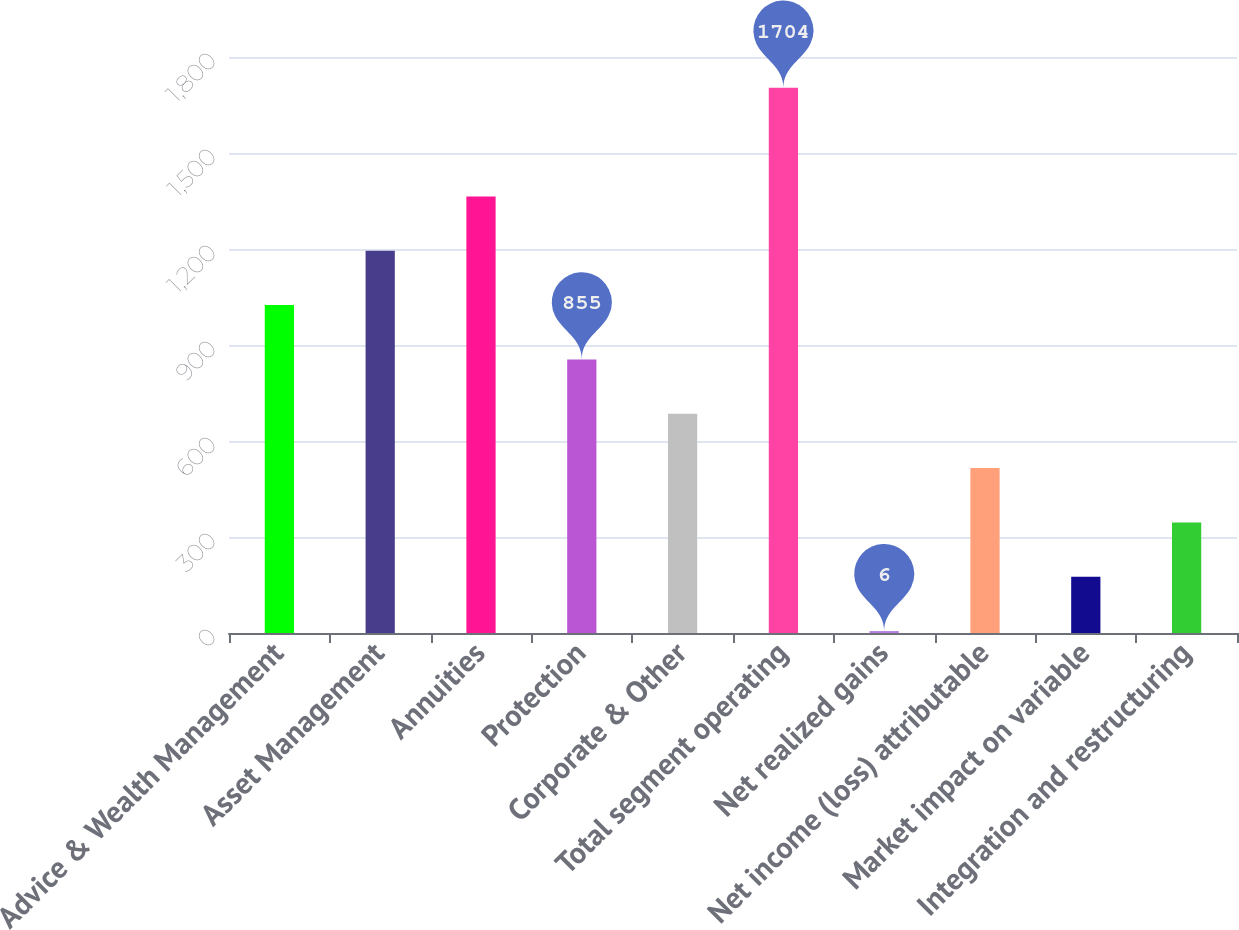<chart> <loc_0><loc_0><loc_500><loc_500><bar_chart><fcel>Advice & Wealth Management<fcel>Asset Management<fcel>Annuities<fcel>Protection<fcel>Corporate & Other<fcel>Total segment operating<fcel>Net realized gains<fcel>Net income (loss) attributable<fcel>Market impact on variable<fcel>Integration and restructuring<nl><fcel>1024.8<fcel>1194.6<fcel>1364.4<fcel>855<fcel>685.2<fcel>1704<fcel>6<fcel>515.4<fcel>175.8<fcel>345.6<nl></chart> 